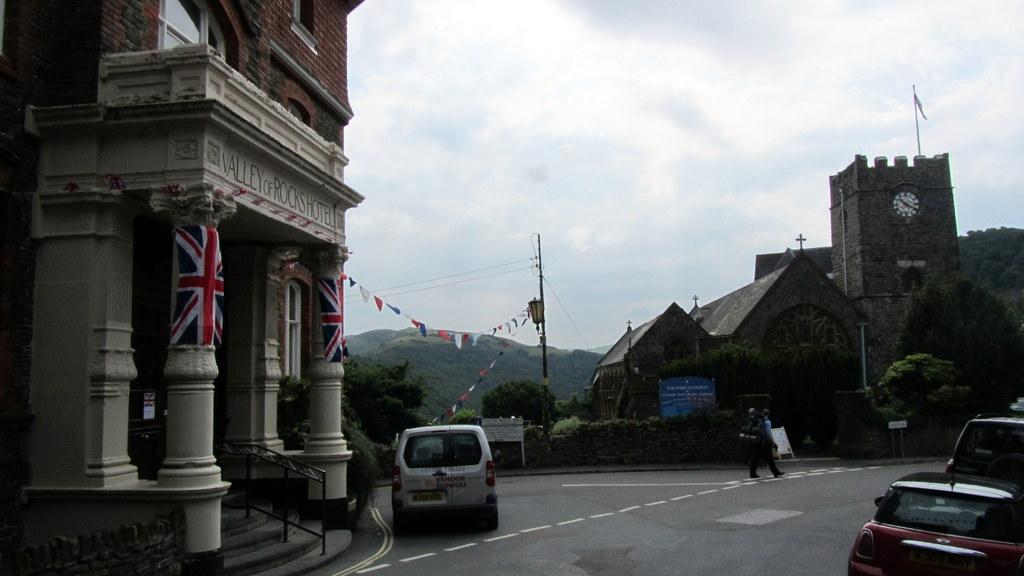Provide a one-sentence caption for the provided image. A landscape shot of a van in front of a hotel called Valley of Rocks Hotel. 